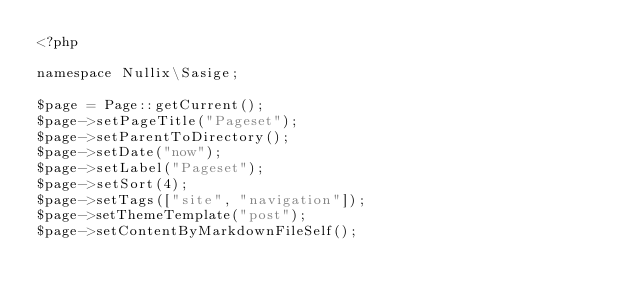Convert code to text. <code><loc_0><loc_0><loc_500><loc_500><_PHP_><?php

namespace Nullix\Sasige;

$page = Page::getCurrent();
$page->setPageTitle("Pageset");
$page->setParentToDirectory();
$page->setDate("now");
$page->setLabel("Pageset");
$page->setSort(4);
$page->setTags(["site", "navigation"]);
$page->setThemeTemplate("post");
$page->setContentByMarkdownFileSelf();</code> 